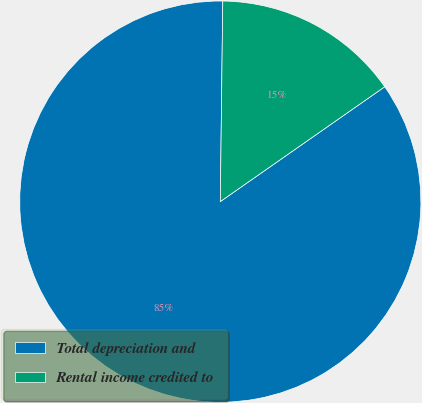Convert chart to OTSL. <chart><loc_0><loc_0><loc_500><loc_500><pie_chart><fcel>Total depreciation and<fcel>Rental income credited to<nl><fcel>84.9%<fcel>15.1%<nl></chart> 